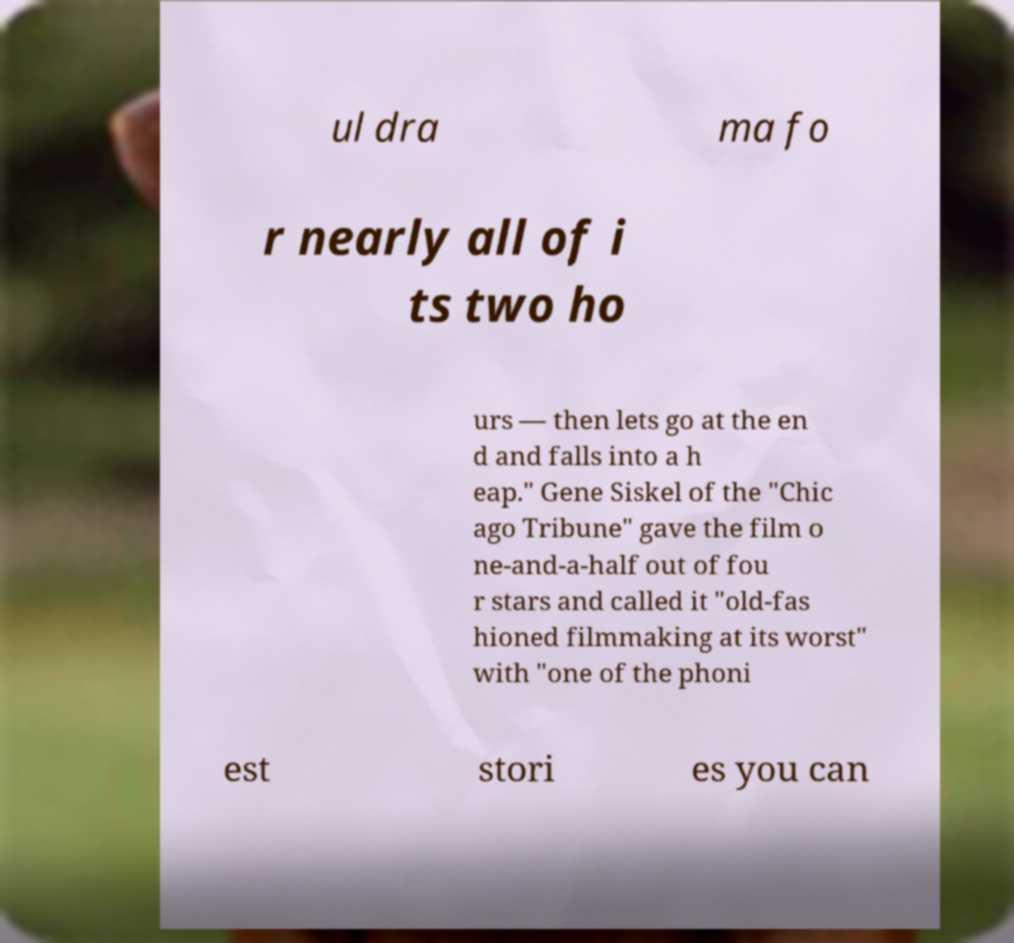Can you accurately transcribe the text from the provided image for me? ul dra ma fo r nearly all of i ts two ho urs — then lets go at the en d and falls into a h eap." Gene Siskel of the "Chic ago Tribune" gave the film o ne-and-a-half out of fou r stars and called it "old-fas hioned filmmaking at its worst" with "one of the phoni est stori es you can 